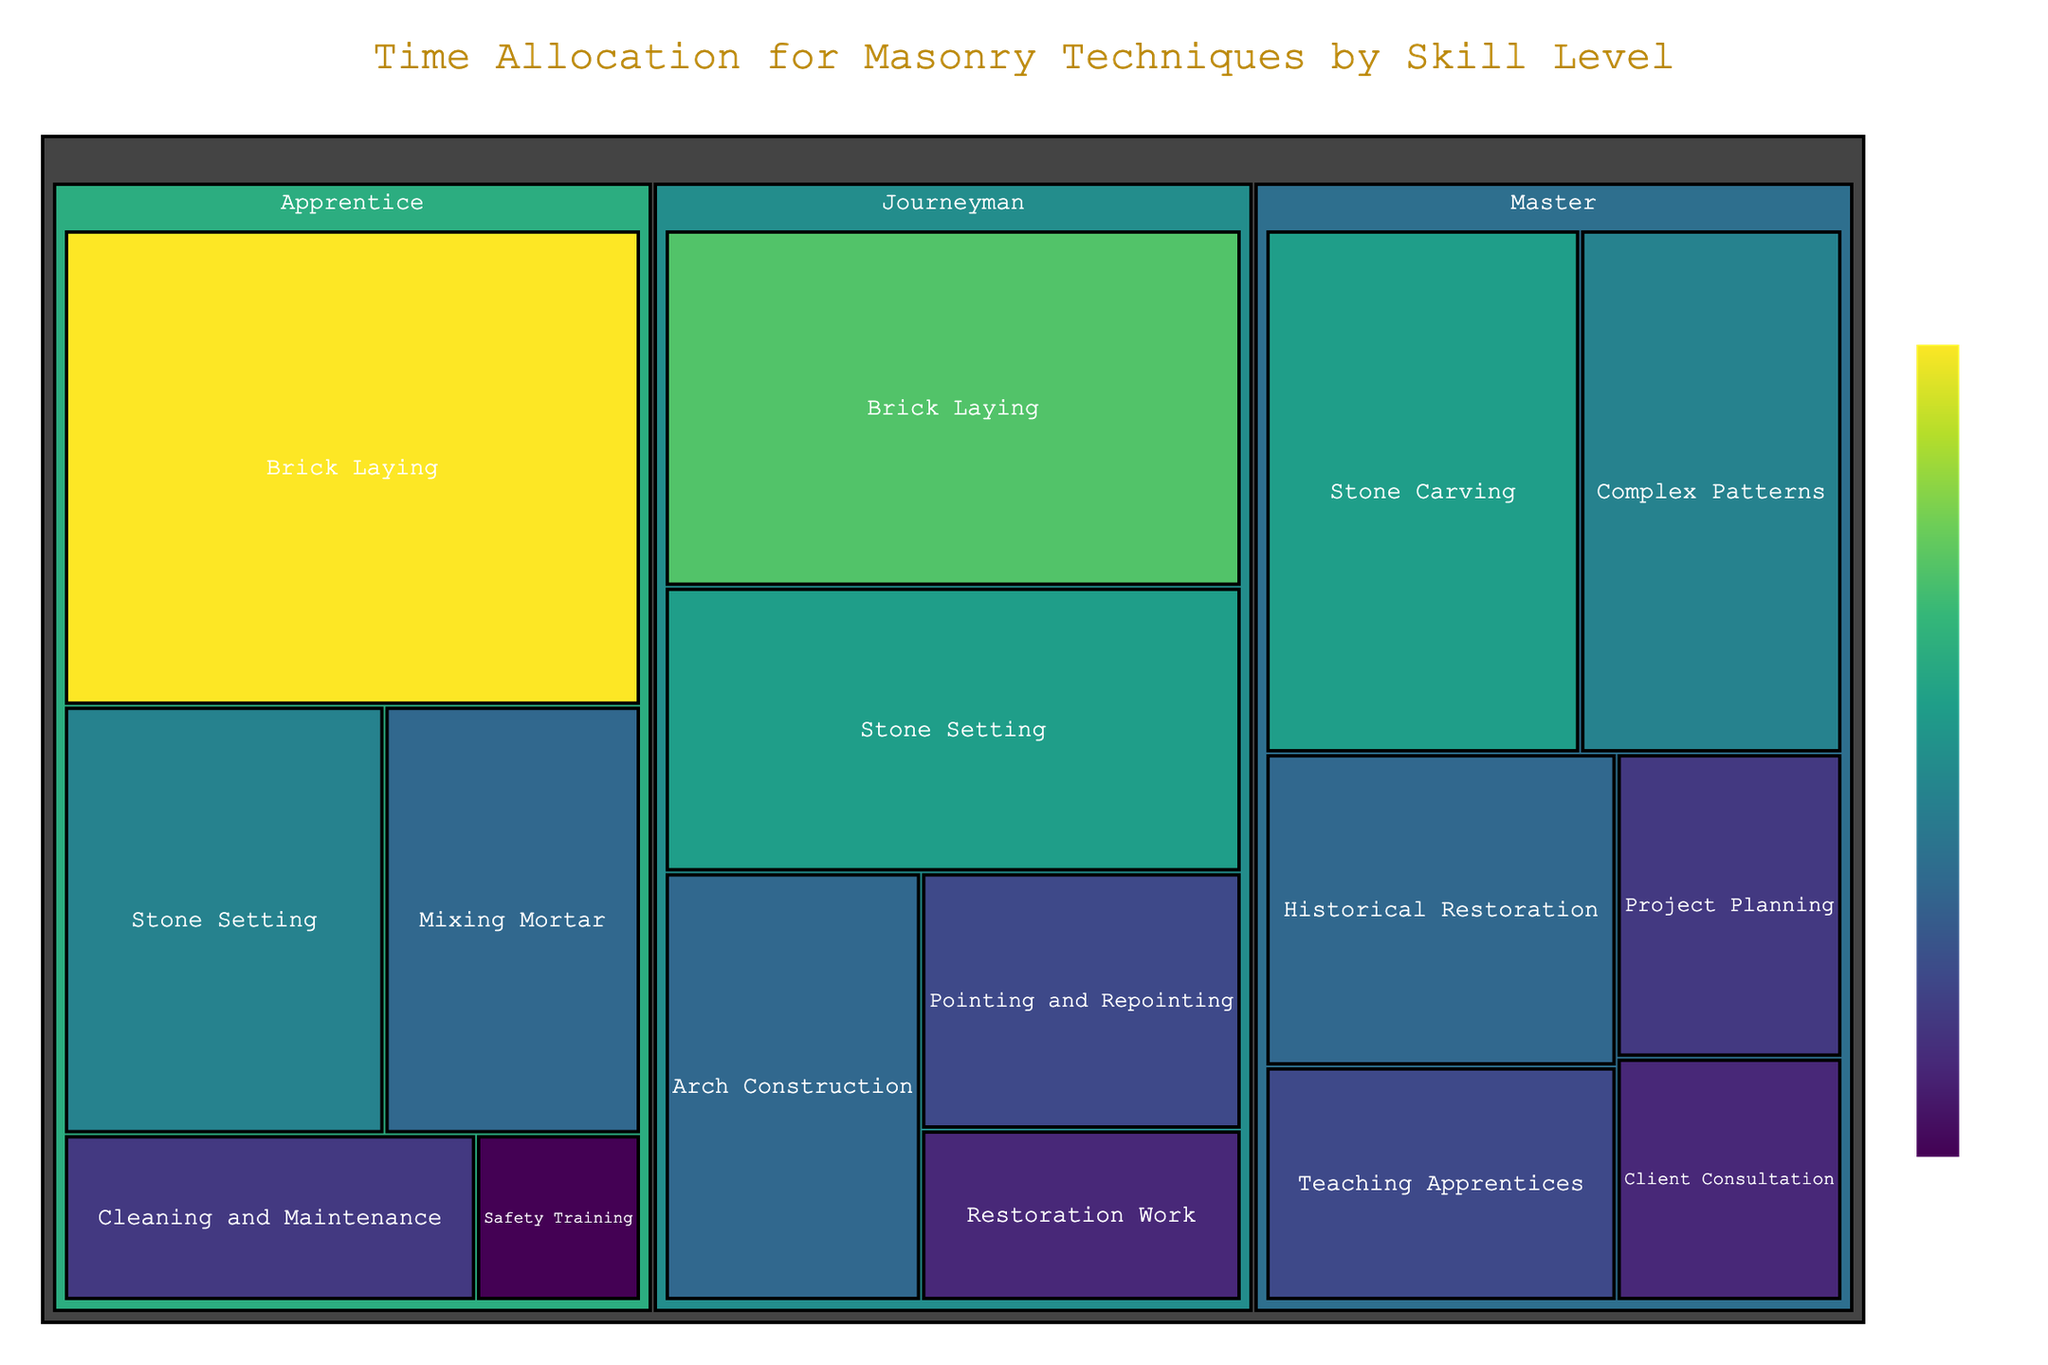What is the title of the figure? The title is usually located at the top of the figure. In this case, it states "Time Allocation for Masonry Techniques by Skill Level".
Answer: Time Allocation for Masonry Techniques by Skill Level How many hours does the Journeyman spend on Stone Setting? To find this, look at the section labeled "Journeyman" and find the portion dedicated to "Stone Setting". According to the data, this section shows 12 hours.
Answer: 12 hours Which technique does the Master spend the most hours on? In the Master's section, identify the technique with the largest area. According to the data and the chart, the Master spends the most time on "Stone Carving" with 12 hours.
Answer: Stone Carving How much total time does an Apprentice spend on Brick Laying and Mixing Mortar? Locate both "Brick Laying" and "Mixing Mortar" under the Apprentice level and sum the hours. Brick Laying is 20 hours, and Mixing Mortar is 8 hours, so 20 + 8 = 28 hours.
Answer: 28 hours What is the least allocated task for the Master? In the Master’s section, find the technique with the smallest area. According to the data and visually from the figure, the Master spends the least time on "Client Consultation", which is 4 hours.
Answer: Client Consultation Which skill level has the most diverse distribution of techniques in terms of hours spent? To determine this, look at the variability in the size of different sections under each skill level. The Master level, with techniques ranging from 4 to 12 hours, seems to have the most diverse allocation.
Answer: Master Compare the time spent on Arch Construction by the Journeyman to Pointing and Repointing. Which one is higher? Locate both techniques under the Journeyman level and compare their values. The Journeyman spends 8 hours on Arch Construction and 6 hours on Pointing and Repointing, so Arch Construction has higher hours.
Answer: Arch Construction What is the sum of hours spent on Cleaning and Maintenance by Apprentices and Restoration Work by Journeymen? Find the hours for each technique: Cleaning and Maintenance (Apprentice) is 5 hours, and Restoration Work (Journeyman) is 4 hours. Sum them up, so 5 + 4 = 9 hours.
Answer: 9 hours Which technique under Apprentice has the second most hours allocated? Identify the techniques under Apprentice and then find the one with the second-largest area. After Brick Laying (20 hours), Stone Setting has 10 hours and is the second most in terms of hours.
Answer: Stone Setting How many hours in total does the Master spend on Teaching Apprentices and Project Planning combined? Locate both techniques under the Master level and sum their hours. Teaching Apprentices is 6 hours and Project Planning is 5 hours, so 6 + 5 = 11 hours.
Answer: 11 hours 